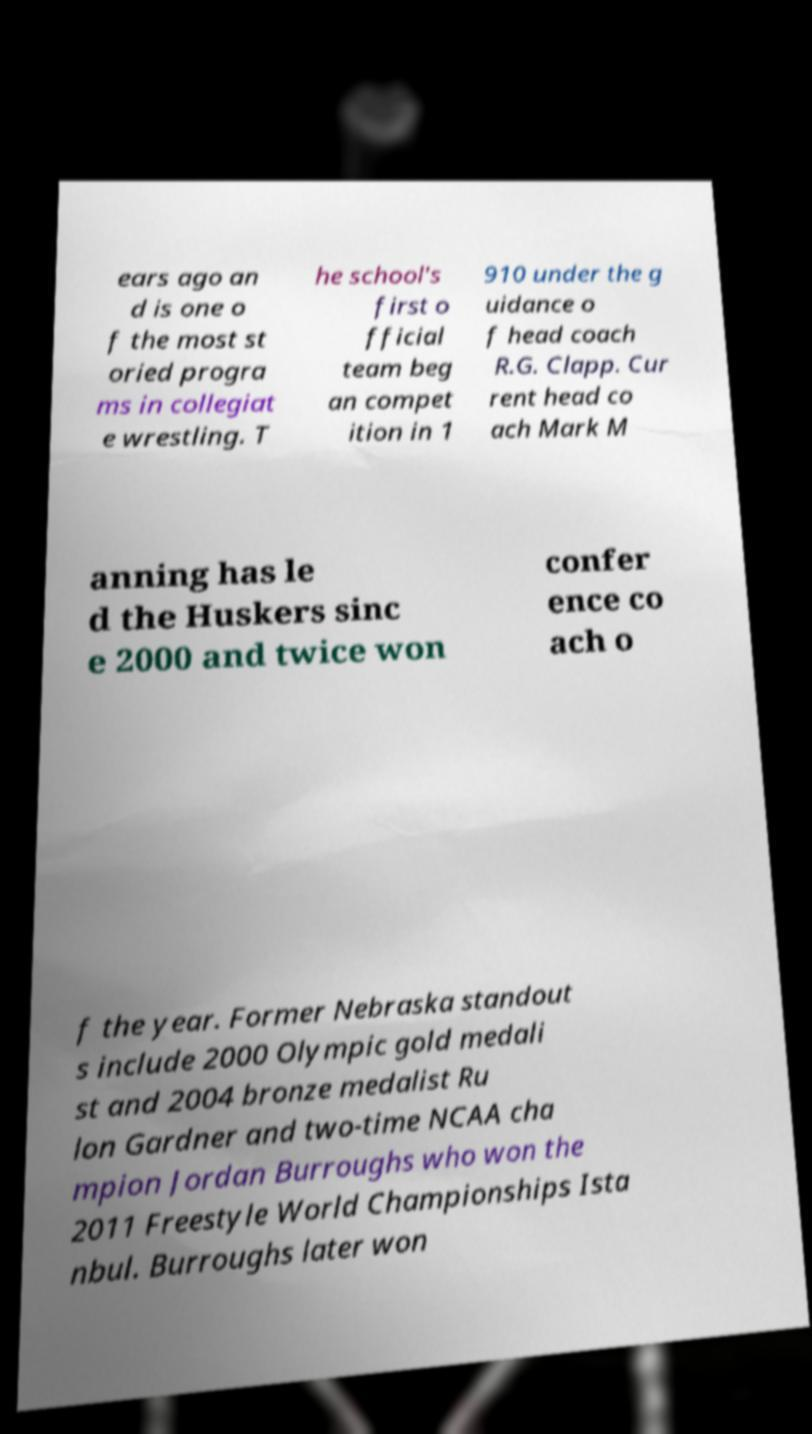Can you read and provide the text displayed in the image?This photo seems to have some interesting text. Can you extract and type it out for me? ears ago an d is one o f the most st oried progra ms in collegiat e wrestling. T he school's first o fficial team beg an compet ition in 1 910 under the g uidance o f head coach R.G. Clapp. Cur rent head co ach Mark M anning has le d the Huskers sinc e 2000 and twice won confer ence co ach o f the year. Former Nebraska standout s include 2000 Olympic gold medali st and 2004 bronze medalist Ru lon Gardner and two-time NCAA cha mpion Jordan Burroughs who won the 2011 Freestyle World Championships Ista nbul. Burroughs later won 